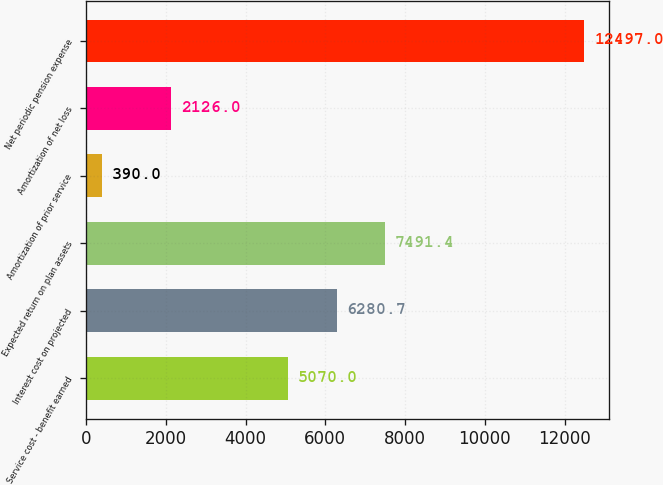<chart> <loc_0><loc_0><loc_500><loc_500><bar_chart><fcel>Service cost - benefit earned<fcel>Interest cost on projected<fcel>Expected return on plan assets<fcel>Amortization of prior service<fcel>Amortization of net loss<fcel>Net periodic pension expense<nl><fcel>5070<fcel>6280.7<fcel>7491.4<fcel>390<fcel>2126<fcel>12497<nl></chart> 